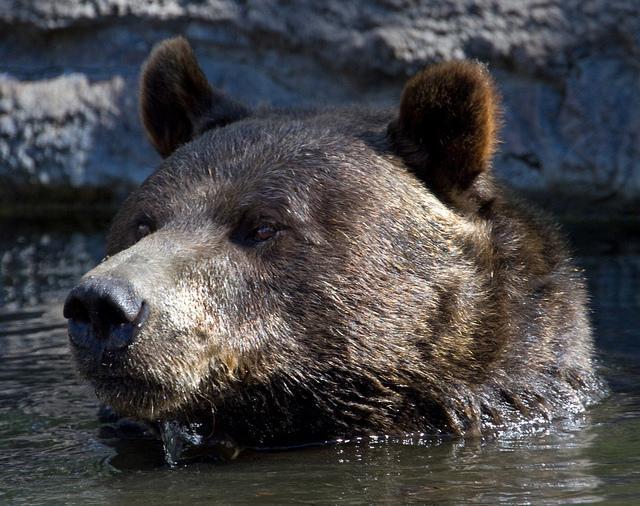How many eyes can be seen?
Give a very brief answer. 2. 